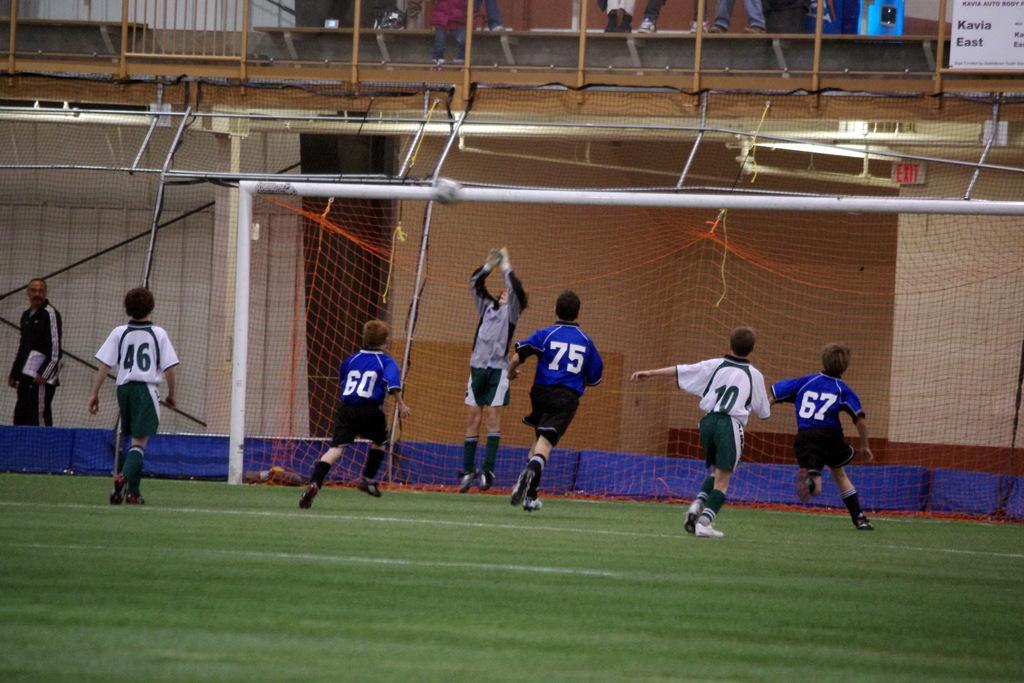Could you give a brief overview of what you see in this image? In this image, we can see people playing in the ground and in the background, there is a mesh and we can see some rods and boards and some people and some other objects. 